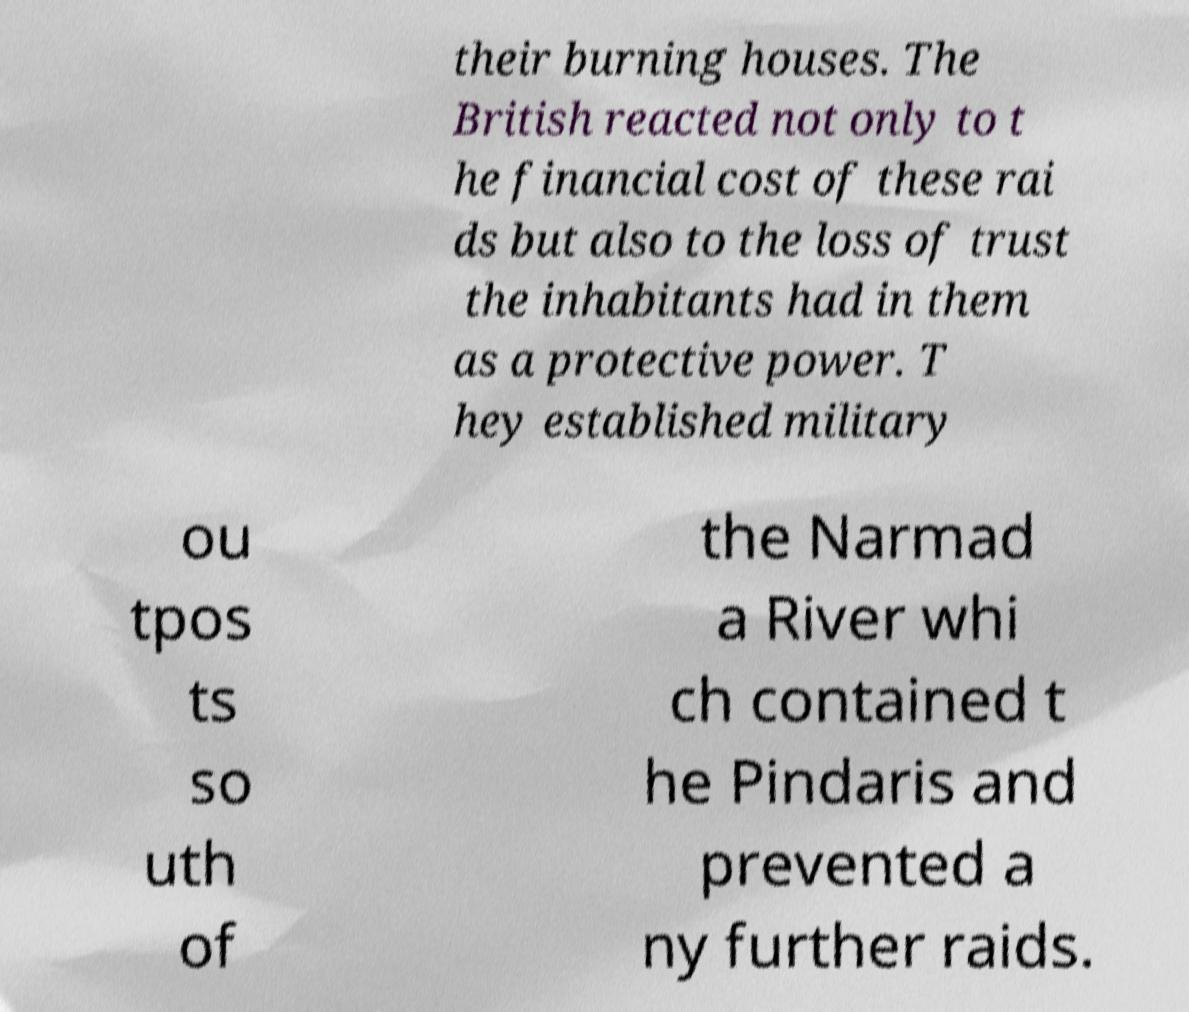There's text embedded in this image that I need extracted. Can you transcribe it verbatim? their burning houses. The British reacted not only to t he financial cost of these rai ds but also to the loss of trust the inhabitants had in them as a protective power. T hey established military ou tpos ts so uth of the Narmad a River whi ch contained t he Pindaris and prevented a ny further raids. 